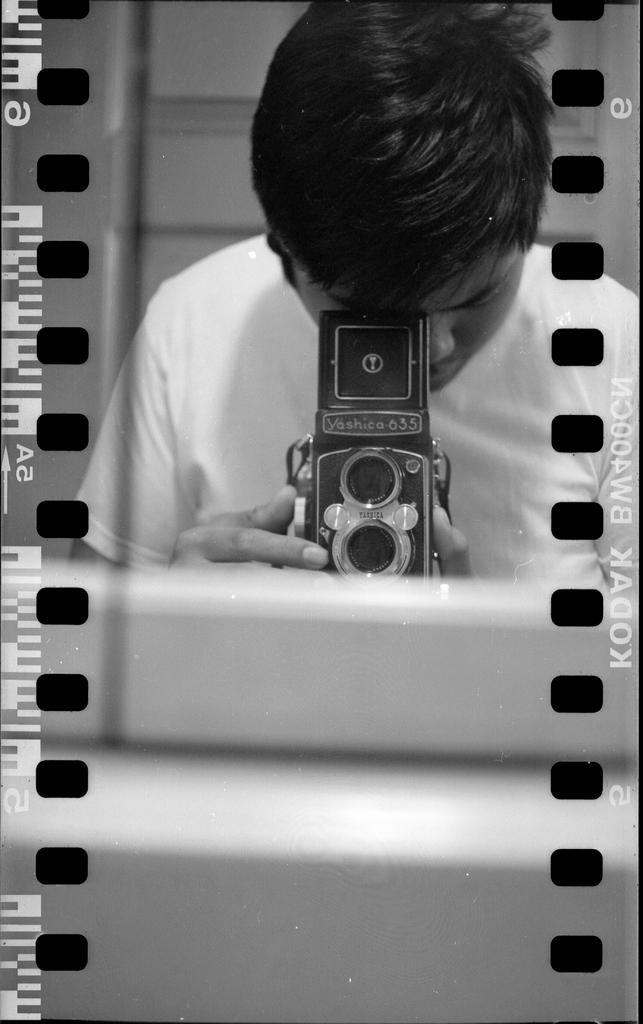Who is the main subject in the image? There is a man in the image. What is the man wearing? The man is wearing a t-shirt. What is the man holding in the image? The man is holding a camera. What is the man doing with the camera? The man is clicking a picture in front of a mirror. How many ducks are visible in the image? There are no ducks present in the image. What day of the week is it in the image? The day of the week is not mentioned or visible in the image. 